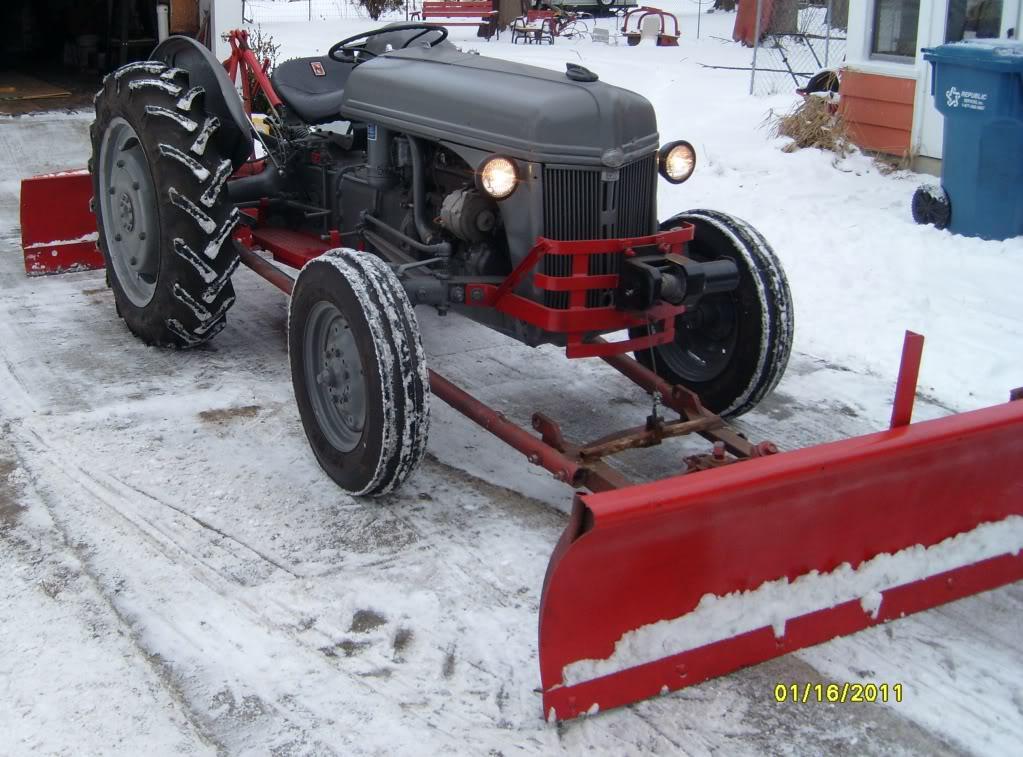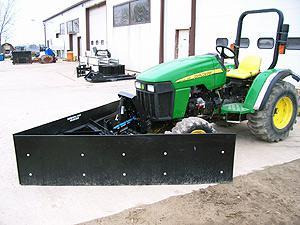The first image is the image on the left, the second image is the image on the right. For the images displayed, is the sentence "The photo on the right shows a snow plow that is not connected to a vehicle and lying on pavement." factually correct? Answer yes or no. No. The first image is the image on the left, the second image is the image on the right. Assess this claim about the two images: "In one image, a black snowplow blade is attached to the front of a vehicle.". Correct or not? Answer yes or no. Yes. 